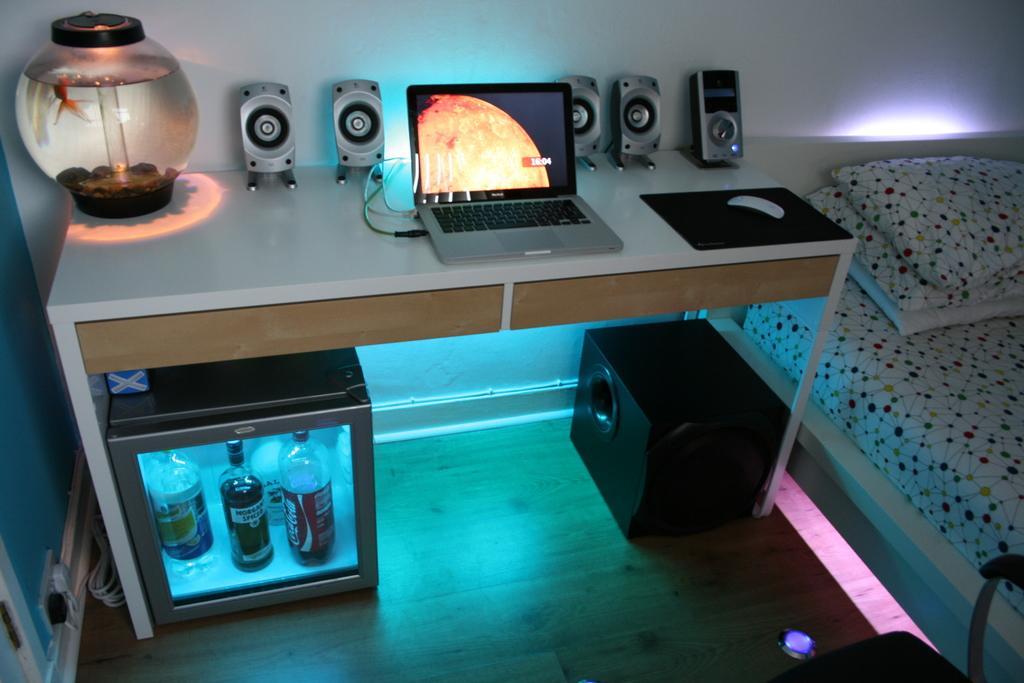Please provide a concise description of this image. In this image there is a bed ,on the bed there are the pillows and beside the bed there is a table ,on the table there is a laptop and there is a fish pot ,under the table there is a bottle kept on the table and there is a speaker on the floor. 